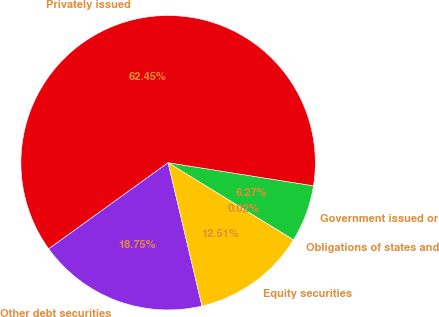Convert chart. <chart><loc_0><loc_0><loc_500><loc_500><pie_chart><fcel>Obligations of states and<fcel>Government issued or<fcel>Privately issued<fcel>Other debt securities<fcel>Equity securities<nl><fcel>0.02%<fcel>6.27%<fcel>62.45%<fcel>18.75%<fcel>12.51%<nl></chart> 